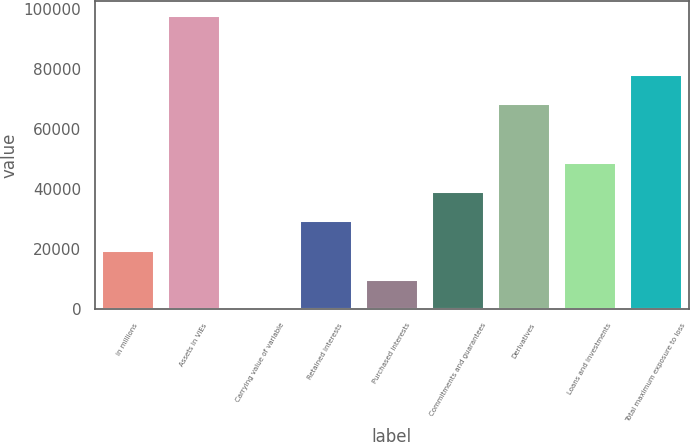<chart> <loc_0><loc_0><loc_500><loc_500><bar_chart><fcel>in millions<fcel>Assets in VIEs<fcel>Carrying value of variable<fcel>Retained interests<fcel>Purchased interests<fcel>Commitments and guarantees<fcel>Derivatives<fcel>Loans and investments<fcel>Total maximum exposure to loss<nl><fcel>19763.6<fcel>97962<fcel>214<fcel>29538.4<fcel>9988.8<fcel>39313.2<fcel>68637.6<fcel>49088<fcel>78412.4<nl></chart> 